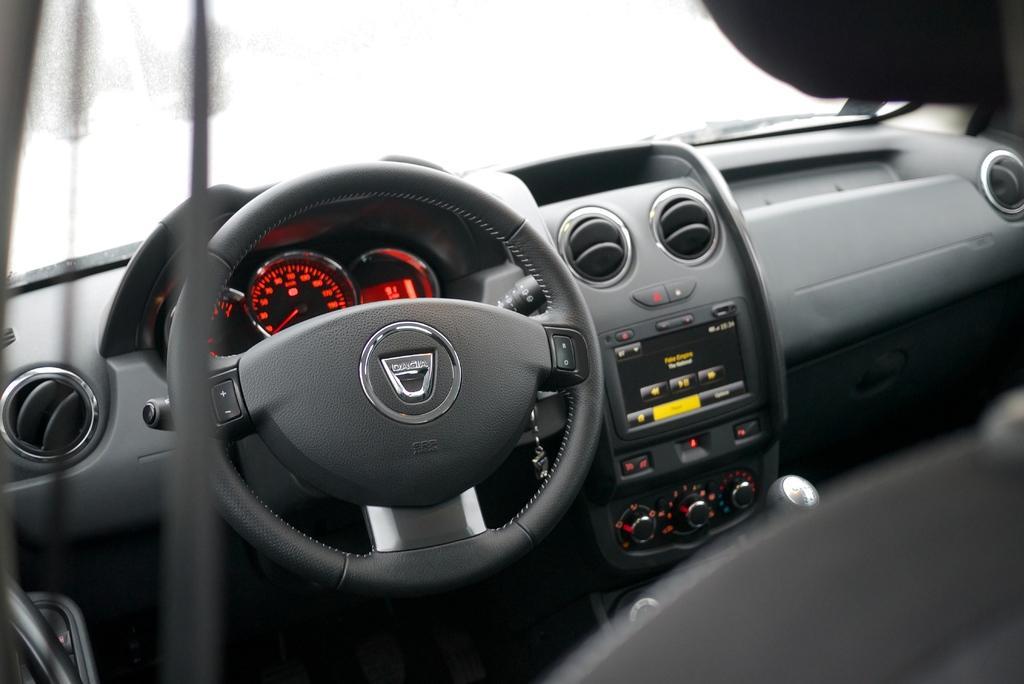Could you give a brief overview of what you see in this image? Here in this picture we can see a dash board, on which we can see a steering, speedometers and music player and AC ducts and knobs and gear rod present all over there and in the front we can see a sind shield present over there. 